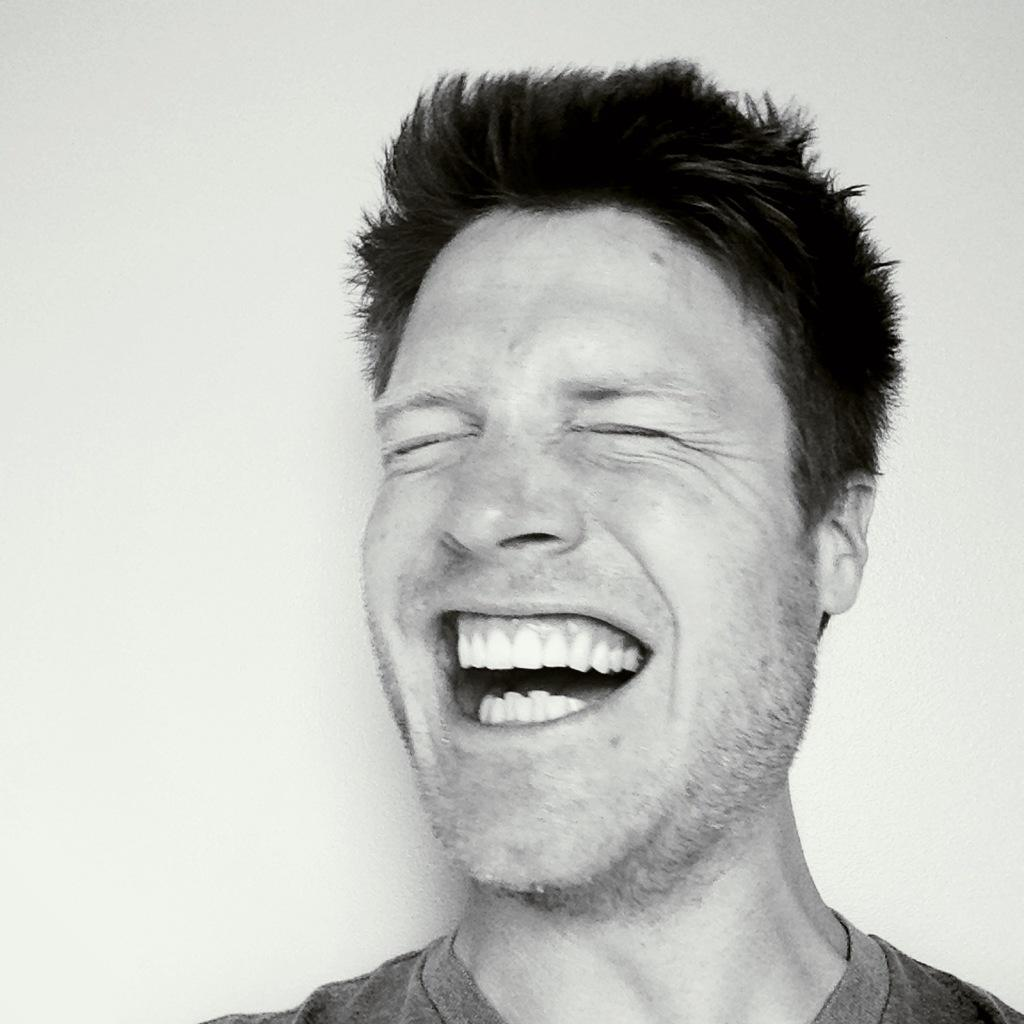What is the main subject of the image? There is a man in the image. What is the man's facial expression in the image? The man is smiling in the image. What color is the background of the image? The background of the image is white. How many houses are on fire in the image? There are no houses or flames present in the image; it features a man smiling against a white background. 